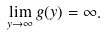Convert formula to latex. <formula><loc_0><loc_0><loc_500><loc_500>\lim _ { y \rightarrow \infty } g ( y ) = \infty .</formula> 